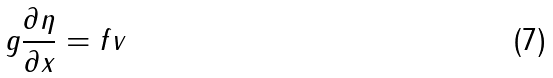Convert formula to latex. <formula><loc_0><loc_0><loc_500><loc_500>g \frac { \partial \eta } { \partial x } = f v</formula> 